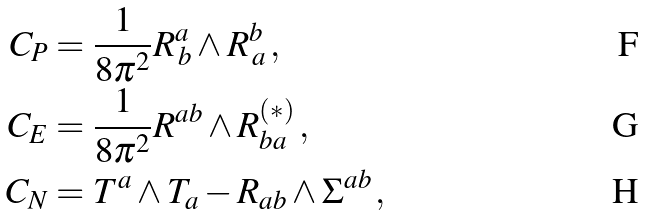Convert formula to latex. <formula><loc_0><loc_0><loc_500><loc_500>C _ { P } & = \frac { 1 } { 8 \pi ^ { 2 } } R ^ { a } _ { \, b } \wedge R ^ { b } _ { \, a } \, , \\ C _ { E } & = \frac { 1 } { 8 \pi ^ { 2 } } R ^ { a b } \wedge R ^ { \left ( * \right ) } _ { b a } \, , \\ C _ { N } & = T ^ { a } \wedge T _ { a } - R _ { a b } \wedge \Sigma ^ { a b } \, ,</formula> 